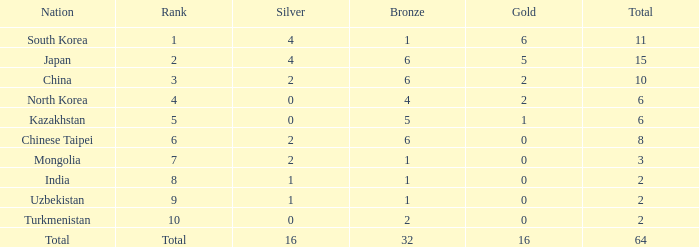What's the biggest Bronze that has less than 0 Silvers? None. 